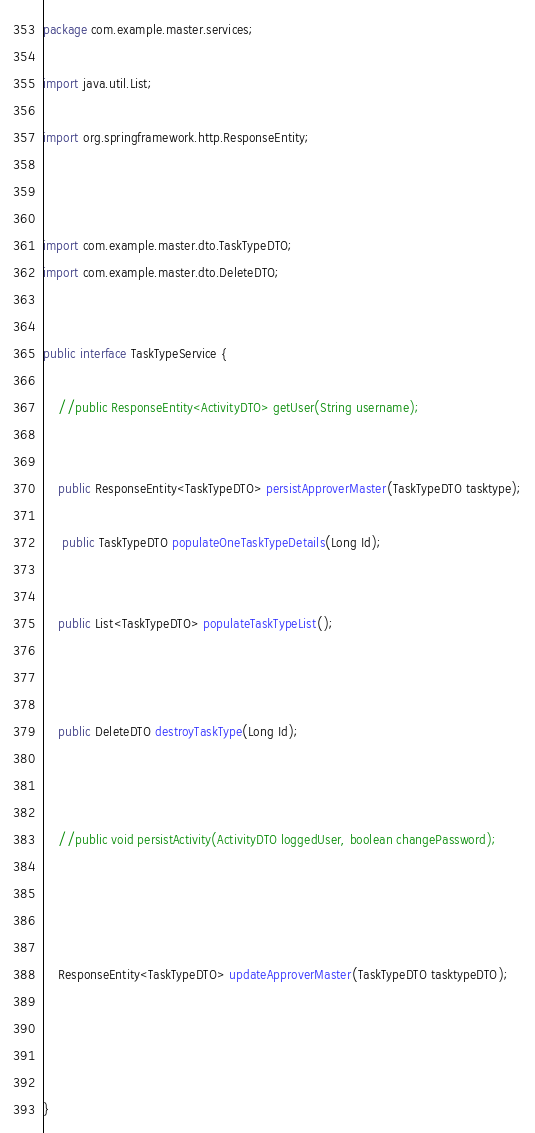<code> <loc_0><loc_0><loc_500><loc_500><_Java_>package com.example.master.services;

import java.util.List;

import org.springframework.http.ResponseEntity;



import com.example.master.dto.TaskTypeDTO;
import com.example.master.dto.DeleteDTO;


public interface TaskTypeService {

    //public ResponseEntity<ActivityDTO> getUser(String username);

	
    public ResponseEntity<TaskTypeDTO> persistApproverMaster(TaskTypeDTO tasktype);
      
     public TaskTypeDTO populateOneTaskTypeDetails(Long Id);
     
    
    public List<TaskTypeDTO> populateTaskTypeList();
    
    

    public DeleteDTO destroyTaskType(Long Id);

   

    //public void persistActivity(ActivityDTO loggedUser, boolean changePassword);

    
  

    ResponseEntity<TaskTypeDTO> updateApproverMaster(TaskTypeDTO tasktypeDTO);
    
    
    

}
</code> 